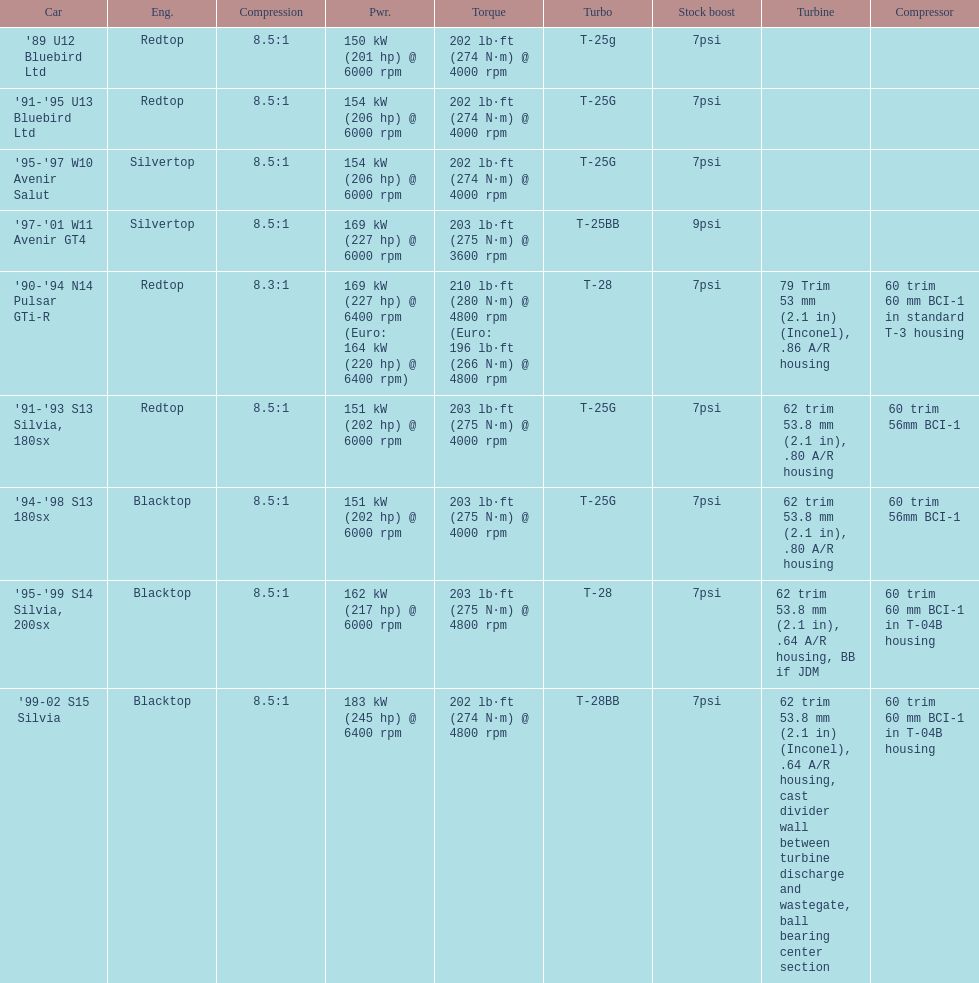Which engines were used after 1999? Silvertop, Blacktop. 